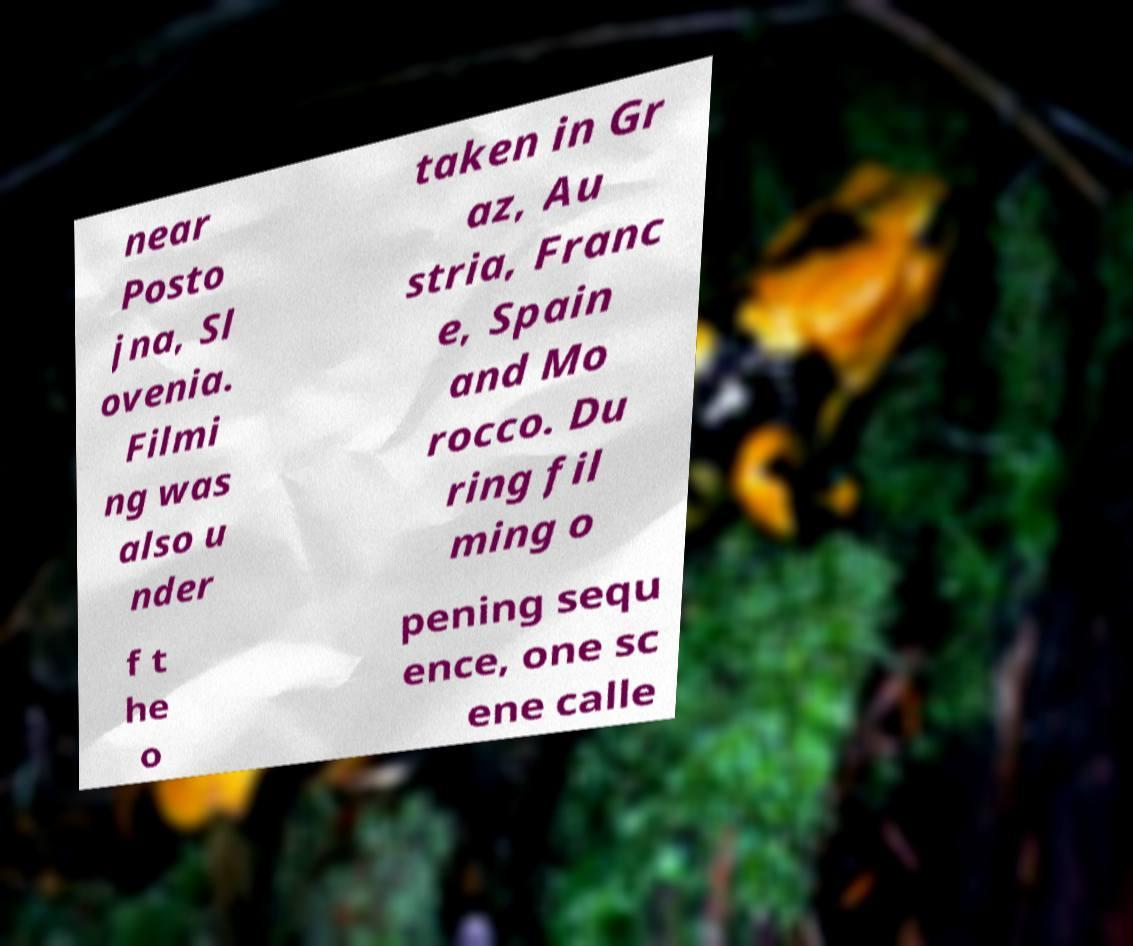What messages or text are displayed in this image? I need them in a readable, typed format. near Posto jna, Sl ovenia. Filmi ng was also u nder taken in Gr az, Au stria, Franc e, Spain and Mo rocco. Du ring fil ming o f t he o pening sequ ence, one sc ene calle 